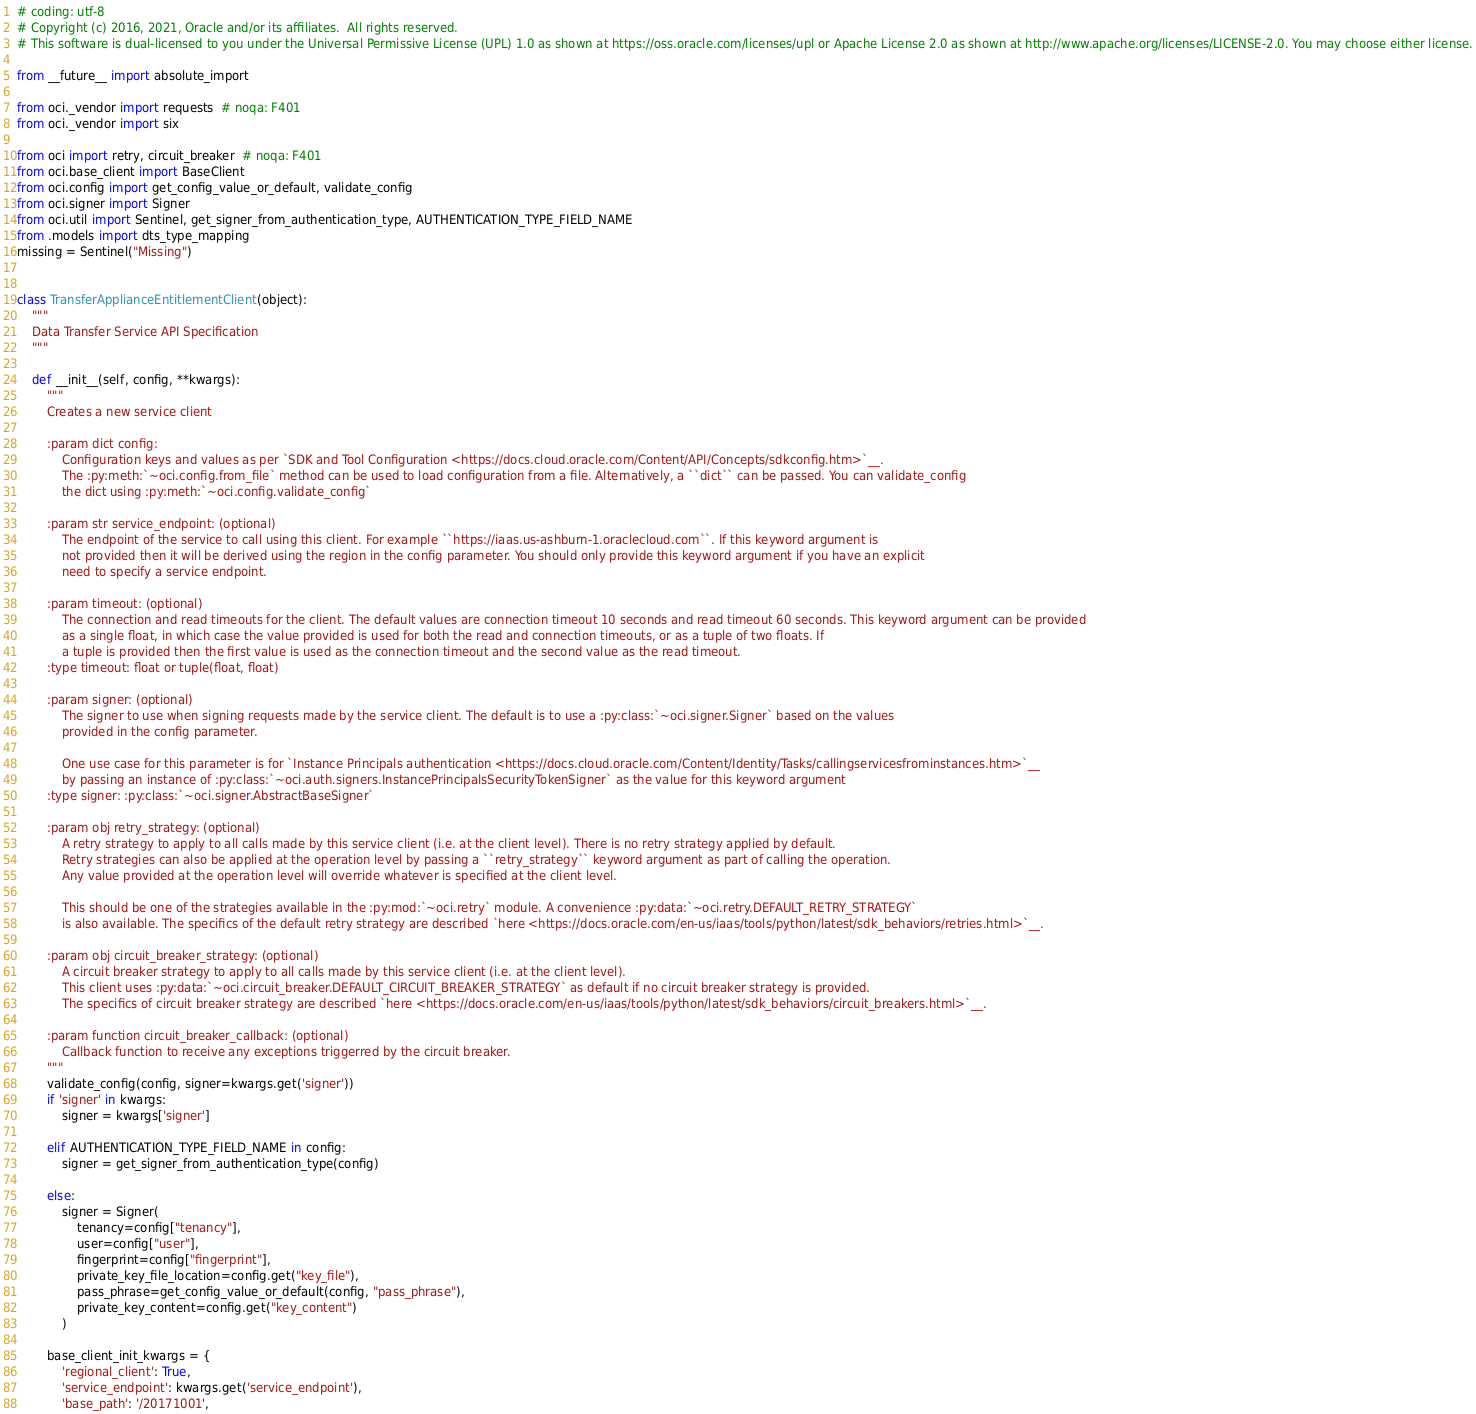<code> <loc_0><loc_0><loc_500><loc_500><_Python_># coding: utf-8
# Copyright (c) 2016, 2021, Oracle and/or its affiliates.  All rights reserved.
# This software is dual-licensed to you under the Universal Permissive License (UPL) 1.0 as shown at https://oss.oracle.com/licenses/upl or Apache License 2.0 as shown at http://www.apache.org/licenses/LICENSE-2.0. You may choose either license.

from __future__ import absolute_import

from oci._vendor import requests  # noqa: F401
from oci._vendor import six

from oci import retry, circuit_breaker  # noqa: F401
from oci.base_client import BaseClient
from oci.config import get_config_value_or_default, validate_config
from oci.signer import Signer
from oci.util import Sentinel, get_signer_from_authentication_type, AUTHENTICATION_TYPE_FIELD_NAME
from .models import dts_type_mapping
missing = Sentinel("Missing")


class TransferApplianceEntitlementClient(object):
    """
    Data Transfer Service API Specification
    """

    def __init__(self, config, **kwargs):
        """
        Creates a new service client

        :param dict config:
            Configuration keys and values as per `SDK and Tool Configuration <https://docs.cloud.oracle.com/Content/API/Concepts/sdkconfig.htm>`__.
            The :py:meth:`~oci.config.from_file` method can be used to load configuration from a file. Alternatively, a ``dict`` can be passed. You can validate_config
            the dict using :py:meth:`~oci.config.validate_config`

        :param str service_endpoint: (optional)
            The endpoint of the service to call using this client. For example ``https://iaas.us-ashburn-1.oraclecloud.com``. If this keyword argument is
            not provided then it will be derived using the region in the config parameter. You should only provide this keyword argument if you have an explicit
            need to specify a service endpoint.

        :param timeout: (optional)
            The connection and read timeouts for the client. The default values are connection timeout 10 seconds and read timeout 60 seconds. This keyword argument can be provided
            as a single float, in which case the value provided is used for both the read and connection timeouts, or as a tuple of two floats. If
            a tuple is provided then the first value is used as the connection timeout and the second value as the read timeout.
        :type timeout: float or tuple(float, float)

        :param signer: (optional)
            The signer to use when signing requests made by the service client. The default is to use a :py:class:`~oci.signer.Signer` based on the values
            provided in the config parameter.

            One use case for this parameter is for `Instance Principals authentication <https://docs.cloud.oracle.com/Content/Identity/Tasks/callingservicesfrominstances.htm>`__
            by passing an instance of :py:class:`~oci.auth.signers.InstancePrincipalsSecurityTokenSigner` as the value for this keyword argument
        :type signer: :py:class:`~oci.signer.AbstractBaseSigner`

        :param obj retry_strategy: (optional)
            A retry strategy to apply to all calls made by this service client (i.e. at the client level). There is no retry strategy applied by default.
            Retry strategies can also be applied at the operation level by passing a ``retry_strategy`` keyword argument as part of calling the operation.
            Any value provided at the operation level will override whatever is specified at the client level.

            This should be one of the strategies available in the :py:mod:`~oci.retry` module. A convenience :py:data:`~oci.retry.DEFAULT_RETRY_STRATEGY`
            is also available. The specifics of the default retry strategy are described `here <https://docs.oracle.com/en-us/iaas/tools/python/latest/sdk_behaviors/retries.html>`__.

        :param obj circuit_breaker_strategy: (optional)
            A circuit breaker strategy to apply to all calls made by this service client (i.e. at the client level).
            This client uses :py:data:`~oci.circuit_breaker.DEFAULT_CIRCUIT_BREAKER_STRATEGY` as default if no circuit breaker strategy is provided.
            The specifics of circuit breaker strategy are described `here <https://docs.oracle.com/en-us/iaas/tools/python/latest/sdk_behaviors/circuit_breakers.html>`__.

        :param function circuit_breaker_callback: (optional)
            Callback function to receive any exceptions triggerred by the circuit breaker.
        """
        validate_config(config, signer=kwargs.get('signer'))
        if 'signer' in kwargs:
            signer = kwargs['signer']

        elif AUTHENTICATION_TYPE_FIELD_NAME in config:
            signer = get_signer_from_authentication_type(config)

        else:
            signer = Signer(
                tenancy=config["tenancy"],
                user=config["user"],
                fingerprint=config["fingerprint"],
                private_key_file_location=config.get("key_file"),
                pass_phrase=get_config_value_or_default(config, "pass_phrase"),
                private_key_content=config.get("key_content")
            )

        base_client_init_kwargs = {
            'regional_client': True,
            'service_endpoint': kwargs.get('service_endpoint'),
            'base_path': '/20171001',</code> 